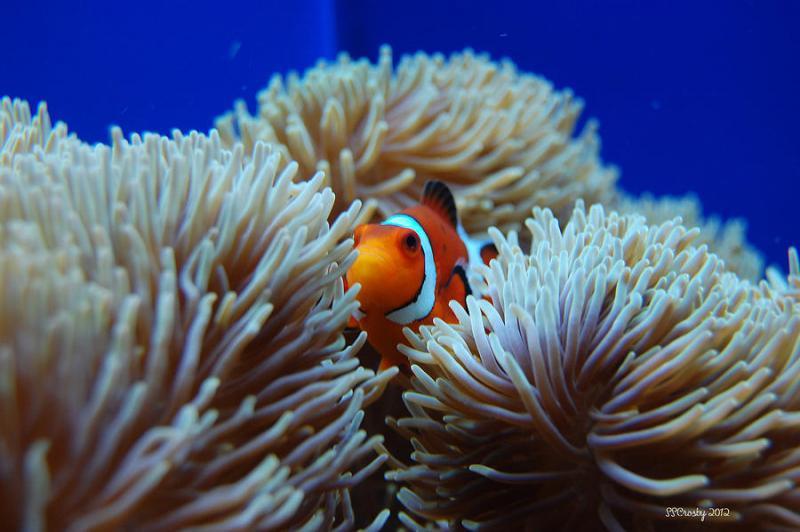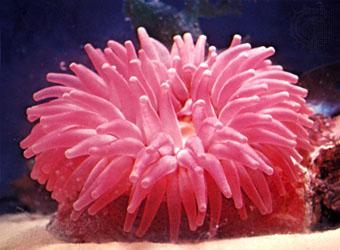The first image is the image on the left, the second image is the image on the right. Considering the images on both sides, is "Exactly one clownfish swims near the center of an image, amid anemone tendrils." valid? Answer yes or no. Yes. 